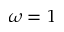Convert formula to latex. <formula><loc_0><loc_0><loc_500><loc_500>\omega = 1</formula> 